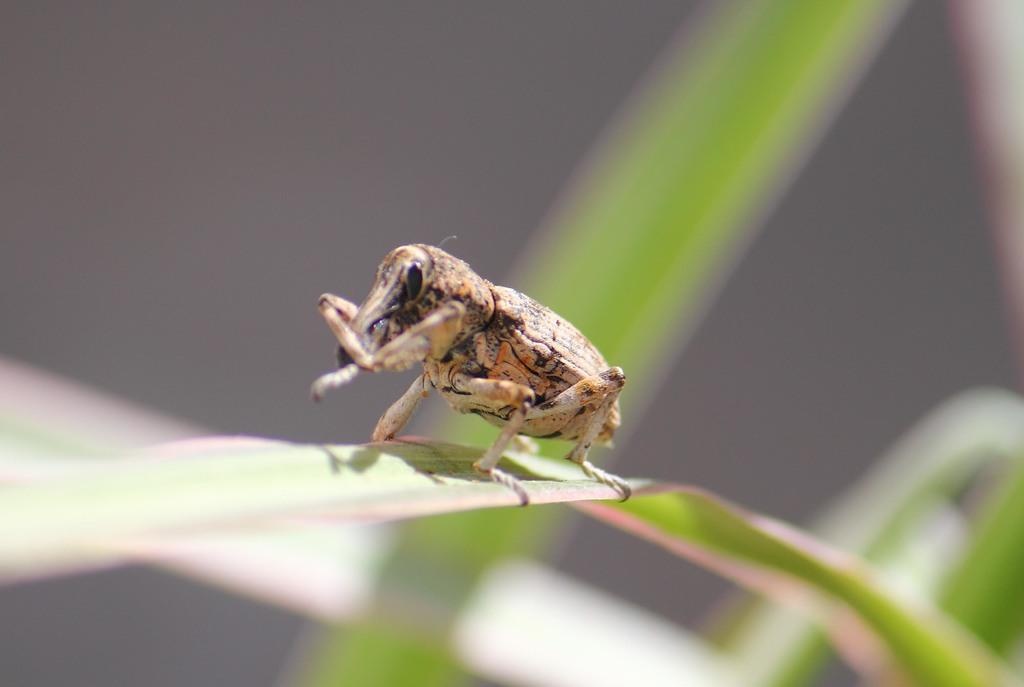What is the main subject of the image? There is an insect in the image. Where is the insect located? The insect is on a leaf. Can you describe the background of the image? The background of the image is blurred. What type of society does the insect belong to in the image? There is no indication of any society in the image; it simply shows an insect on a leaf. 